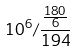Convert formula to latex. <formula><loc_0><loc_0><loc_500><loc_500>1 0 ^ { 6 } / \frac { \frac { 1 8 0 } { 6 } } { 1 9 4 }</formula> 